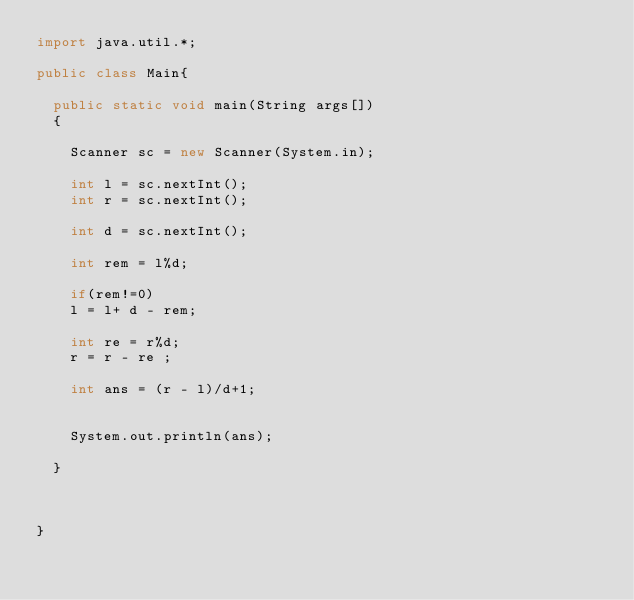Convert code to text. <code><loc_0><loc_0><loc_500><loc_500><_Java_>import java.util.*;
 
public class Main{
 
  public static void main(String args[])
  {
   
    Scanner sc = new Scanner(System.in);
    
    int l = sc.nextInt();
    int r = sc.nextInt();
    
    int d = sc.nextInt();
    
    int rem = l%d;
    
    if(rem!=0)
    l = l+ d - rem;
    
    int re = r%d;
    r = r - re ;
    
    int ans = (r - l)/d+1;
   
    
    System.out.println(ans);
    
  }
  
  
  
}</code> 